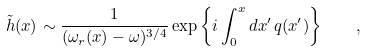<formula> <loc_0><loc_0><loc_500><loc_500>\tilde { h } ( x ) \sim \frac { 1 } { ( \omega _ { r } ( x ) - \omega ) ^ { 3 / 4 } } \exp \left \{ i \int _ { 0 } ^ { x } d x ^ { \prime } \, q ( x ^ { \prime } ) \right \} \quad ,</formula> 